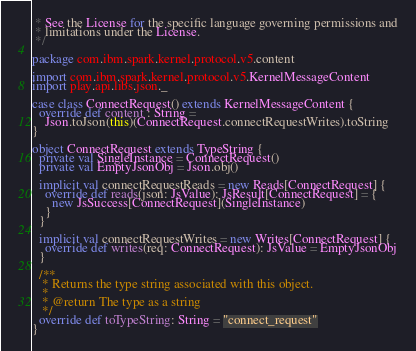<code> <loc_0><loc_0><loc_500><loc_500><_Scala_> * See the License for the specific language governing permissions and
 * limitations under the License.
 */

package com.ibm.spark.kernel.protocol.v5.content

import com.ibm.spark.kernel.protocol.v5.KernelMessageContent
import play.api.libs.json._

case class ConnectRequest() extends KernelMessageContent {
  override def content : String =
    Json.toJson(this)(ConnectRequest.connectRequestWrites).toString
}

object ConnectRequest extends TypeString {
  private val SingleInstance = ConnectRequest()
  private val EmptyJsonObj = Json.obj()

  implicit val connectRequestReads = new Reads[ConnectRequest] {
    override def reads(json: JsValue): JsResult[ConnectRequest] = {
      new JsSuccess[ConnectRequest](SingleInstance)
    }
  }

  implicit val connectRequestWrites = new Writes[ConnectRequest] {
    override def writes(req: ConnectRequest): JsValue = EmptyJsonObj
  }

  /**
   * Returns the type string associated with this object.
   *
   * @return The type as a string
   */
  override def toTypeString: String = "connect_request"
}
</code> 